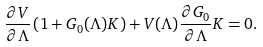Convert formula to latex. <formula><loc_0><loc_0><loc_500><loc_500>\frac { \partial V } { \partial \Lambda } \left ( 1 + G _ { 0 } ( \Lambda ) K \right ) + V ( \Lambda ) \frac { \partial G _ { 0 } } { \partial \Lambda } K = 0 .</formula> 